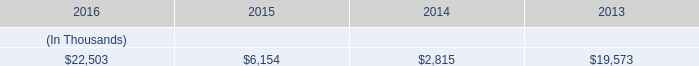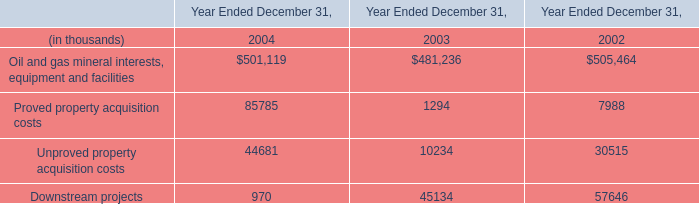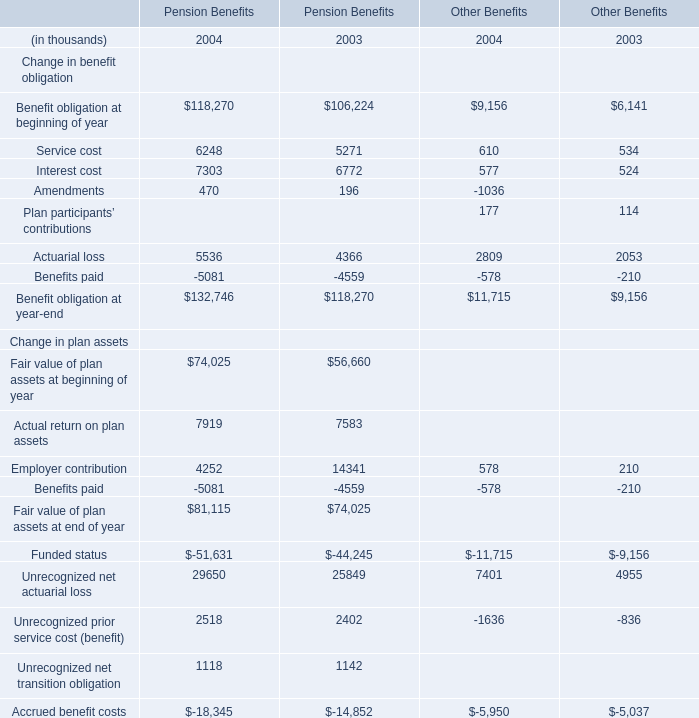What's the sum of Interest cost of Pension Benefits 2004, and Unproved property acquisition costs of Year Ended December 31, 2002 ? 
Computations: (7303.0 + 30515.0)
Answer: 37818.0. 